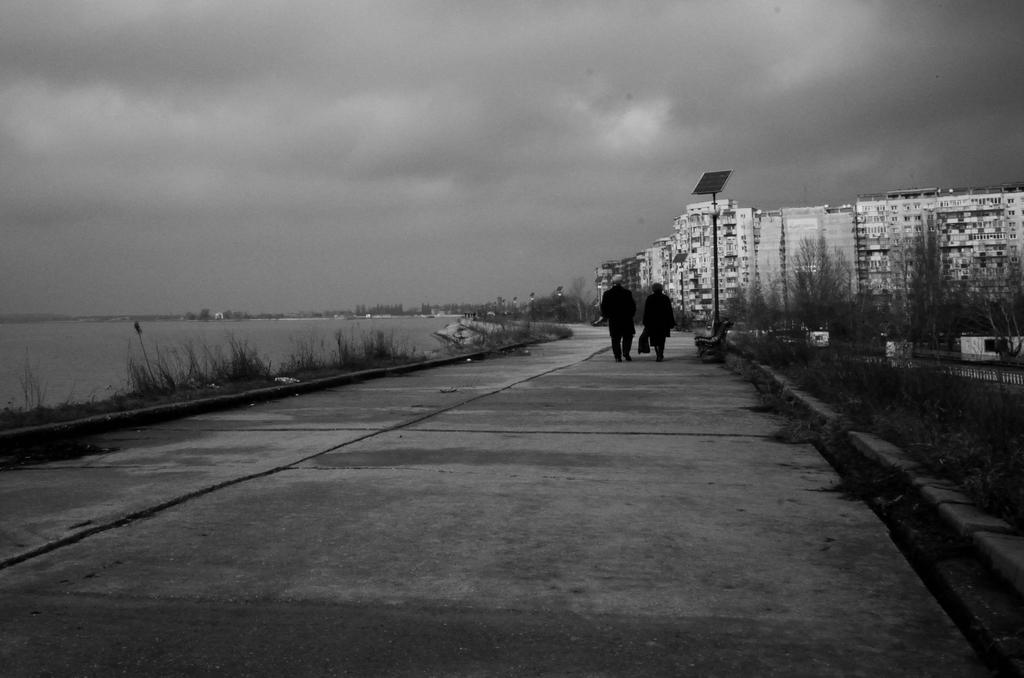What type of structures can be seen in the image? There are buildings in the image. What is the condition of the trees in the image? Dry trees are present in the image. What natural element is visible in the image? There is water visible in the image. Can you describe the people in the image? There are people in the image. What part of the environment can be seen in the image? The sky is visible in the image. What type of energy-generating devices are present in the image? Solar panels on stands are present in the image. What type of lipstick is the achiever wearing in the image? There is no mention of an achiever or lipstick in the image; it features buildings, dry trees, water, people, the sky, and solar panels. What type of business is being conducted in the image? There is no indication of any business activity in the image. 